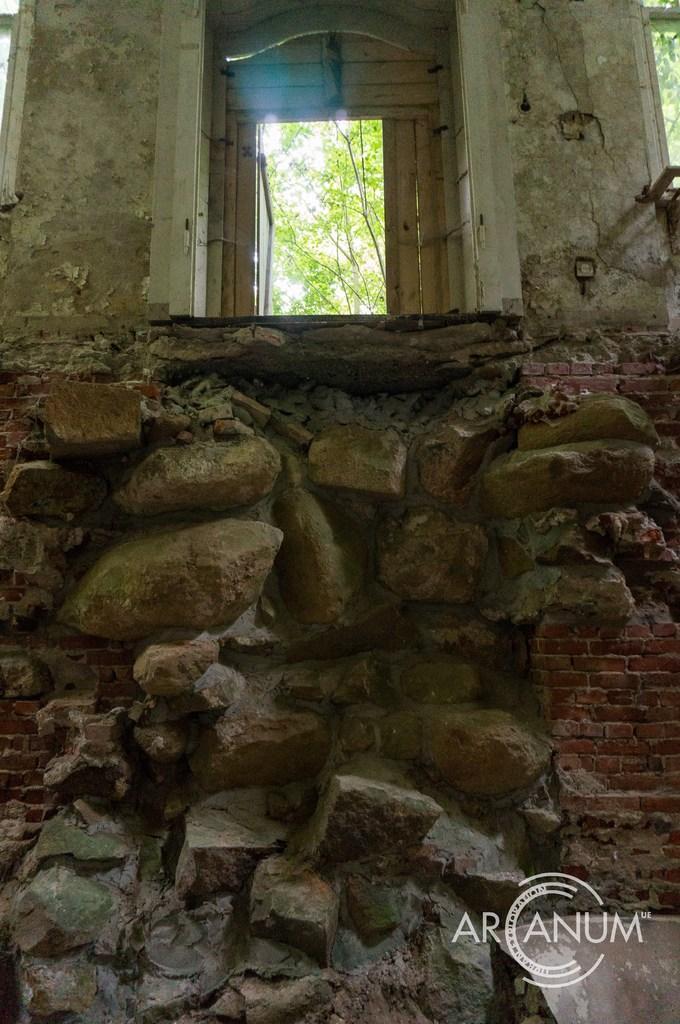How would you summarize this image in a sentence or two? In this picture we find a abandoned home and a wooden door. There is also a stonehenge type of wall. A label is found down named as ARANUM. 